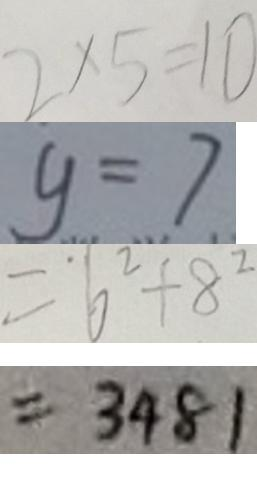Convert formula to latex. <formula><loc_0><loc_0><loc_500><loc_500>2 \times 5 = 1 0 
 y = 7 
 = 6 ^ { 2 } + 8 ^ { 2 } 
 = 3 4 8 1</formula> 